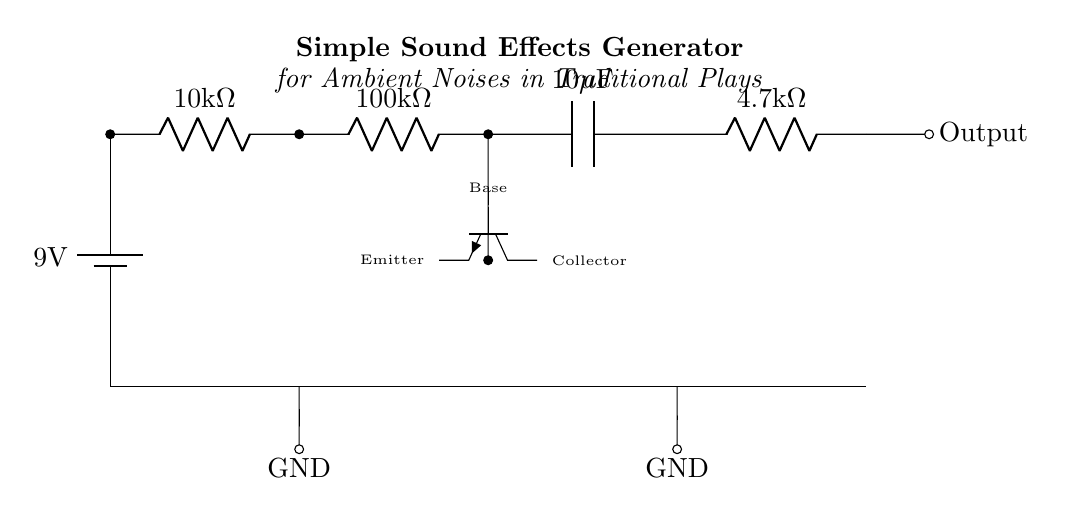What is the voltage of this circuit? The voltage is 9 Volts, which is the value indicated on the battery connected to the circuit.
Answer: 9 Volts What type of transistor is used in this circuit? The circuit uses an NPN transistor, which is identified by the label 'npn' in the diagram.
Answer: NPN How many resistors are present in the circuit? There are four resistors visible in the circuit diagram, indicated by their symbols and values.
Answer: Four What is the capacitance value in the circuit? The circuit includes a capacitor with a capacitance value of 10 microfarads, as shown in the capacitor label.
Answer: 10 microfarads Why is the 100 kilohm resistor connected in series with the other components? The 100 kilohm resistor serves as a current-limiting component, helping to set the base current for the transistor and impact circuit behavior. This is important for controlling the output sound levels.
Answer: Current-limiting What are the ground connections in this circuit? The circuit has two ground connections; one is directly connected to the battery's negative terminal, and the other is connected to the lower nodes of two resistors and the capacitor.
Answer: Two ground connections What role does the 4.7 kilohm resistor play in this circuit? The 4.7 kilohm resistor is typically used to control the transistor's collector current, impacting the output sound levels generated by the circuit.
Answer: Collector current control 